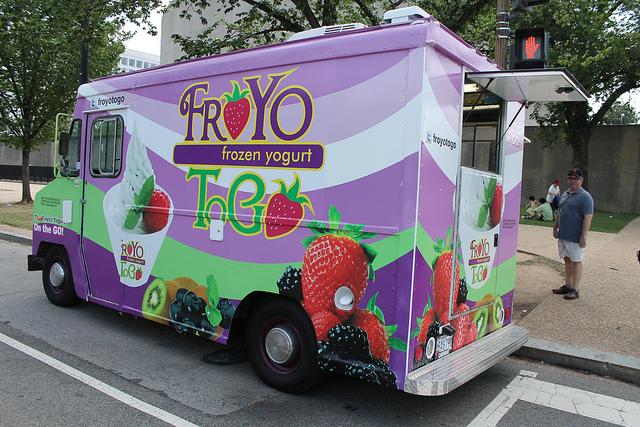What fruit is seen in the cup on the truck?

Choices:
A) mango
B) blueberry
C) raspberry
D) banana raspberry 